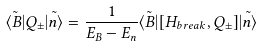<formula> <loc_0><loc_0><loc_500><loc_500>\tilde { \langle B | } Q _ { \pm } \tilde { | n \rangle } = \frac { 1 } { E _ { B } - E _ { n } } \tilde { \langle B | } [ H _ { b r e a k } , Q _ { \pm } ] \tilde { | n \rangle }</formula> 